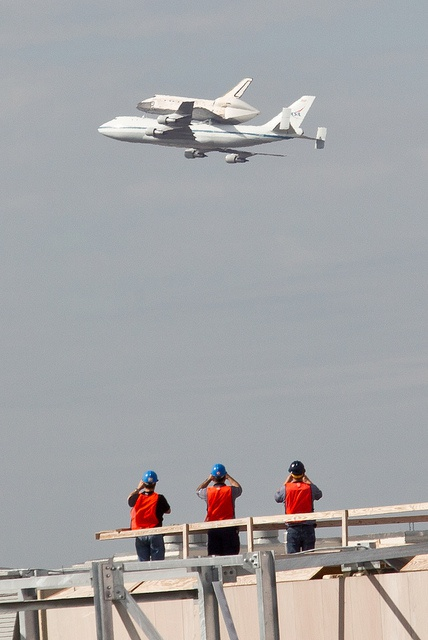Describe the objects in this image and their specific colors. I can see airplane in darkgray, lightgray, and gray tones, people in darkgray, black, maroon, and red tones, people in darkgray, black, maroon, red, and gray tones, and people in darkgray, black, maroon, red, and navy tones in this image. 